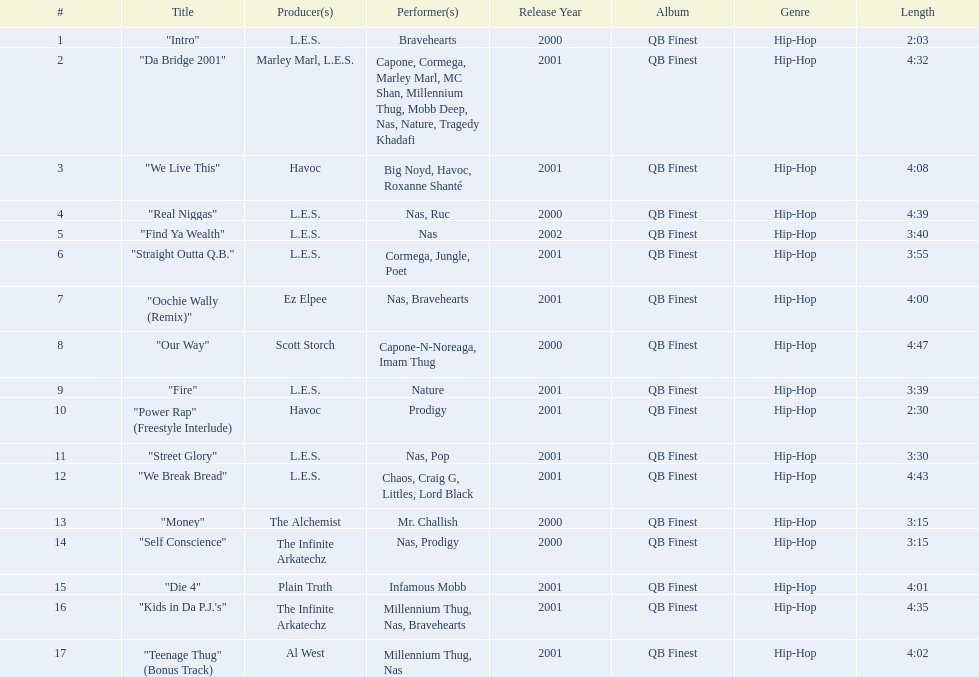How long is each song? 2:03, 4:32, 4:08, 4:39, 3:40, 3:55, 4:00, 4:47, 3:39, 2:30, 3:30, 4:43, 3:15, 3:15, 4:01, 4:35, 4:02. What length is the longest? 4:47. 